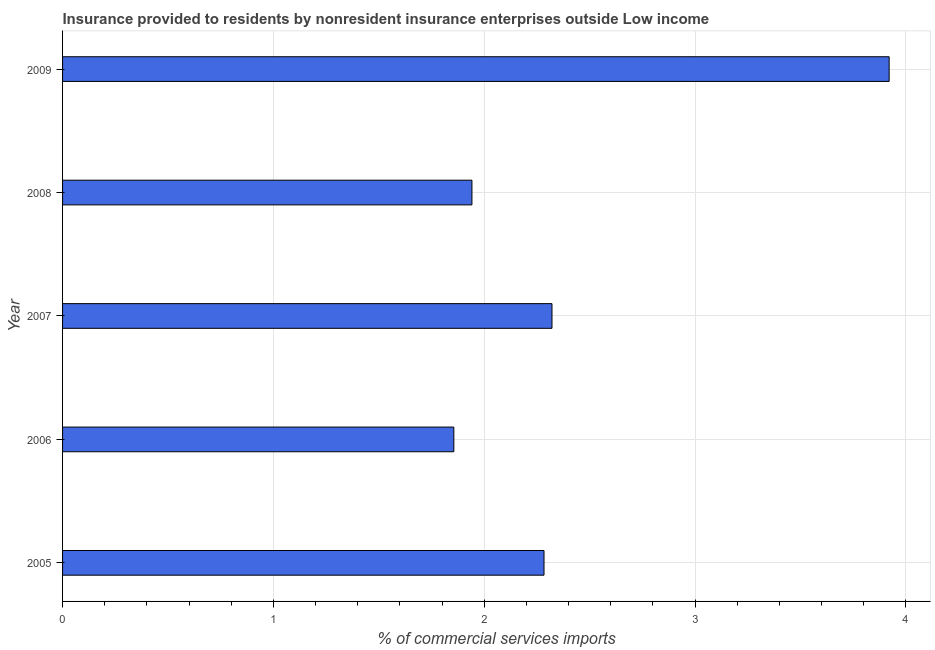Does the graph contain grids?
Make the answer very short. Yes. What is the title of the graph?
Keep it short and to the point. Insurance provided to residents by nonresident insurance enterprises outside Low income. What is the label or title of the X-axis?
Your response must be concise. % of commercial services imports. What is the insurance provided by non-residents in 2005?
Your answer should be compact. 2.28. Across all years, what is the maximum insurance provided by non-residents?
Give a very brief answer. 3.92. Across all years, what is the minimum insurance provided by non-residents?
Make the answer very short. 1.86. In which year was the insurance provided by non-residents maximum?
Provide a succinct answer. 2009. What is the sum of the insurance provided by non-residents?
Give a very brief answer. 12.32. What is the difference between the insurance provided by non-residents in 2008 and 2009?
Make the answer very short. -1.98. What is the average insurance provided by non-residents per year?
Provide a short and direct response. 2.46. What is the median insurance provided by non-residents?
Your response must be concise. 2.28. Do a majority of the years between 2008 and 2006 (inclusive) have insurance provided by non-residents greater than 2.6 %?
Offer a terse response. Yes. What is the ratio of the insurance provided by non-residents in 2007 to that in 2008?
Provide a short and direct response. 1.2. What is the difference between the highest and the second highest insurance provided by non-residents?
Your response must be concise. 1.6. What is the difference between the highest and the lowest insurance provided by non-residents?
Provide a short and direct response. 2.06. How many bars are there?
Offer a very short reply. 5. What is the % of commercial services imports of 2005?
Make the answer very short. 2.28. What is the % of commercial services imports in 2006?
Your answer should be very brief. 1.86. What is the % of commercial services imports in 2007?
Ensure brevity in your answer.  2.32. What is the % of commercial services imports of 2008?
Your response must be concise. 1.94. What is the % of commercial services imports of 2009?
Your answer should be compact. 3.92. What is the difference between the % of commercial services imports in 2005 and 2006?
Your answer should be compact. 0.43. What is the difference between the % of commercial services imports in 2005 and 2007?
Provide a short and direct response. -0.04. What is the difference between the % of commercial services imports in 2005 and 2008?
Provide a short and direct response. 0.34. What is the difference between the % of commercial services imports in 2005 and 2009?
Offer a very short reply. -1.64. What is the difference between the % of commercial services imports in 2006 and 2007?
Keep it short and to the point. -0.47. What is the difference between the % of commercial services imports in 2006 and 2008?
Your response must be concise. -0.09. What is the difference between the % of commercial services imports in 2006 and 2009?
Keep it short and to the point. -2.06. What is the difference between the % of commercial services imports in 2007 and 2008?
Ensure brevity in your answer.  0.38. What is the difference between the % of commercial services imports in 2007 and 2009?
Provide a short and direct response. -1.6. What is the difference between the % of commercial services imports in 2008 and 2009?
Offer a terse response. -1.98. What is the ratio of the % of commercial services imports in 2005 to that in 2006?
Provide a short and direct response. 1.23. What is the ratio of the % of commercial services imports in 2005 to that in 2007?
Offer a terse response. 0.98. What is the ratio of the % of commercial services imports in 2005 to that in 2008?
Give a very brief answer. 1.18. What is the ratio of the % of commercial services imports in 2005 to that in 2009?
Give a very brief answer. 0.58. What is the ratio of the % of commercial services imports in 2006 to that in 2007?
Make the answer very short. 0.8. What is the ratio of the % of commercial services imports in 2006 to that in 2008?
Offer a terse response. 0.96. What is the ratio of the % of commercial services imports in 2006 to that in 2009?
Provide a succinct answer. 0.47. What is the ratio of the % of commercial services imports in 2007 to that in 2008?
Keep it short and to the point. 1.2. What is the ratio of the % of commercial services imports in 2007 to that in 2009?
Provide a short and direct response. 0.59. What is the ratio of the % of commercial services imports in 2008 to that in 2009?
Offer a very short reply. 0.49. 